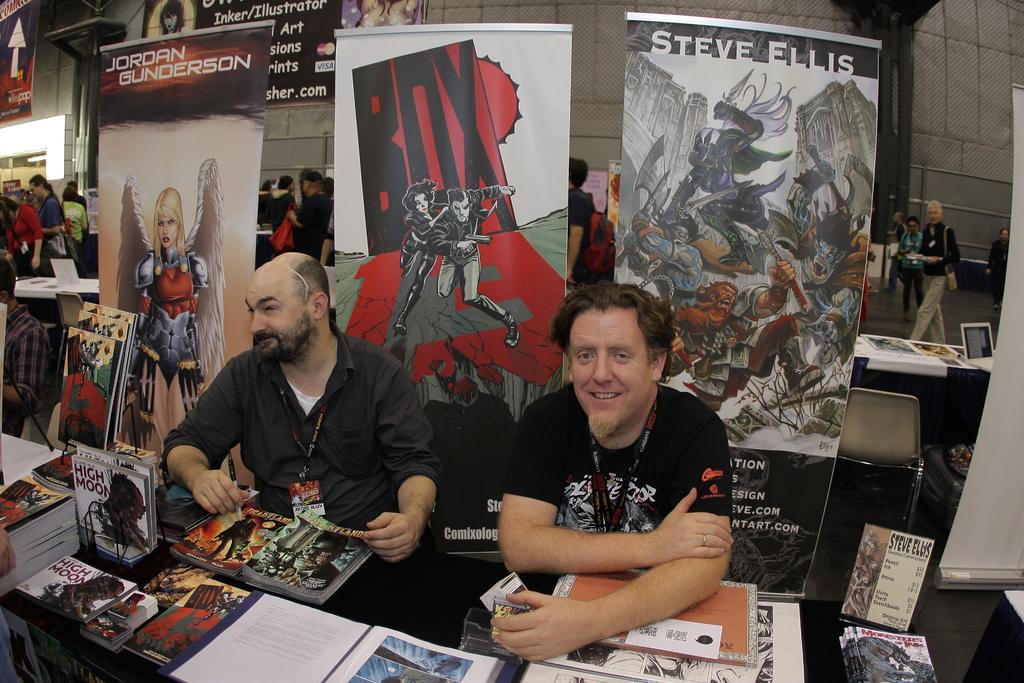Provide a one-sentence caption for the provided image. Two men at a table behind the one on the right is a poster topped with the name: Steve Ellis. 